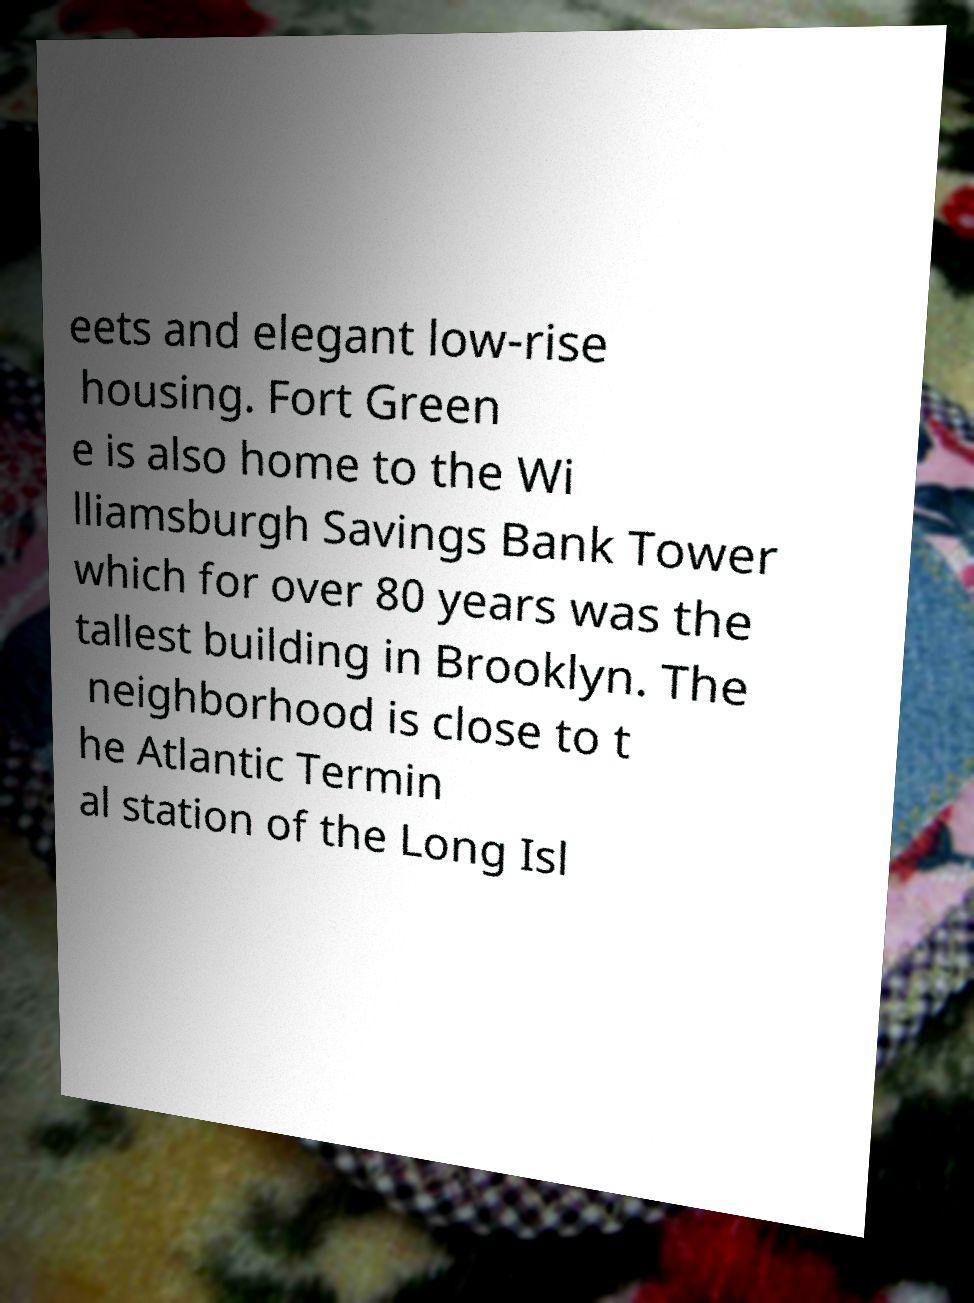There's text embedded in this image that I need extracted. Can you transcribe it verbatim? eets and elegant low-rise housing. Fort Green e is also home to the Wi lliamsburgh Savings Bank Tower which for over 80 years was the tallest building in Brooklyn. The neighborhood is close to t he Atlantic Termin al station of the Long Isl 